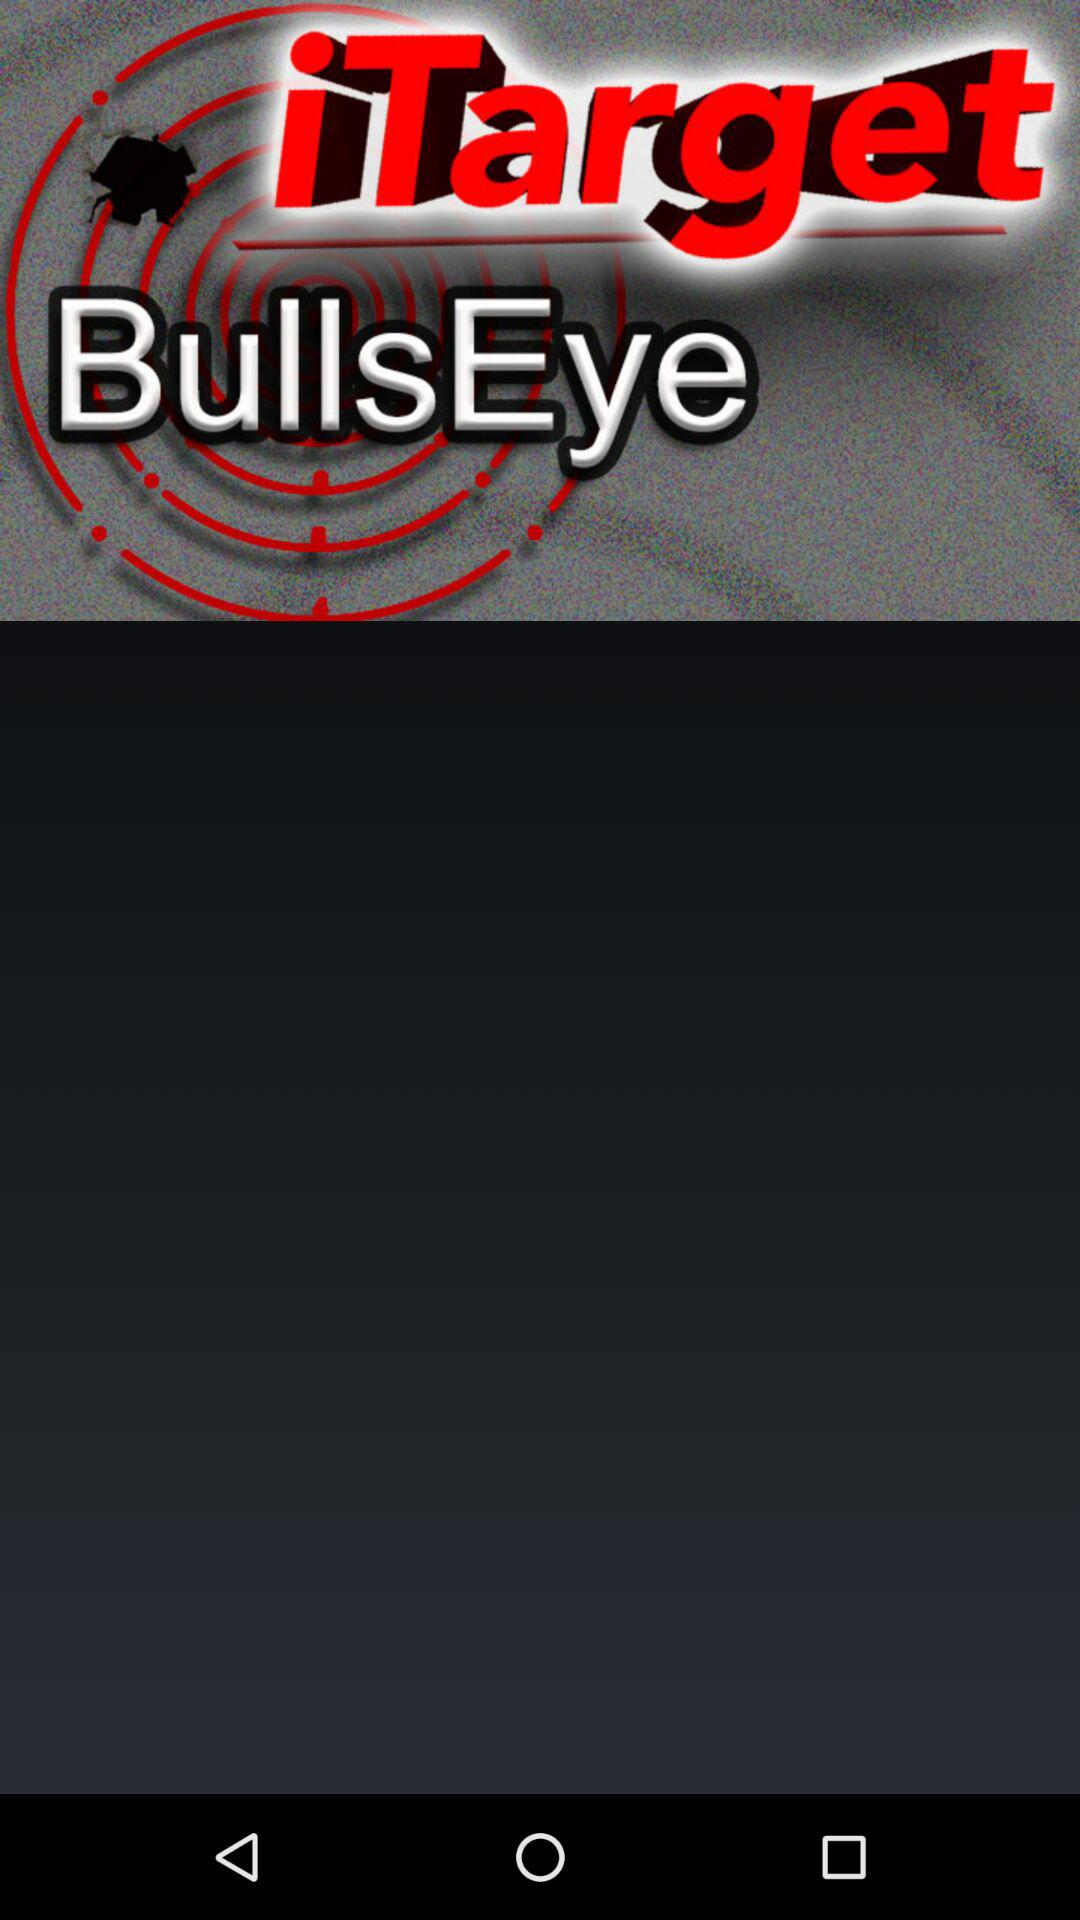What is the name of the application? The name of the application is "iTarget". 